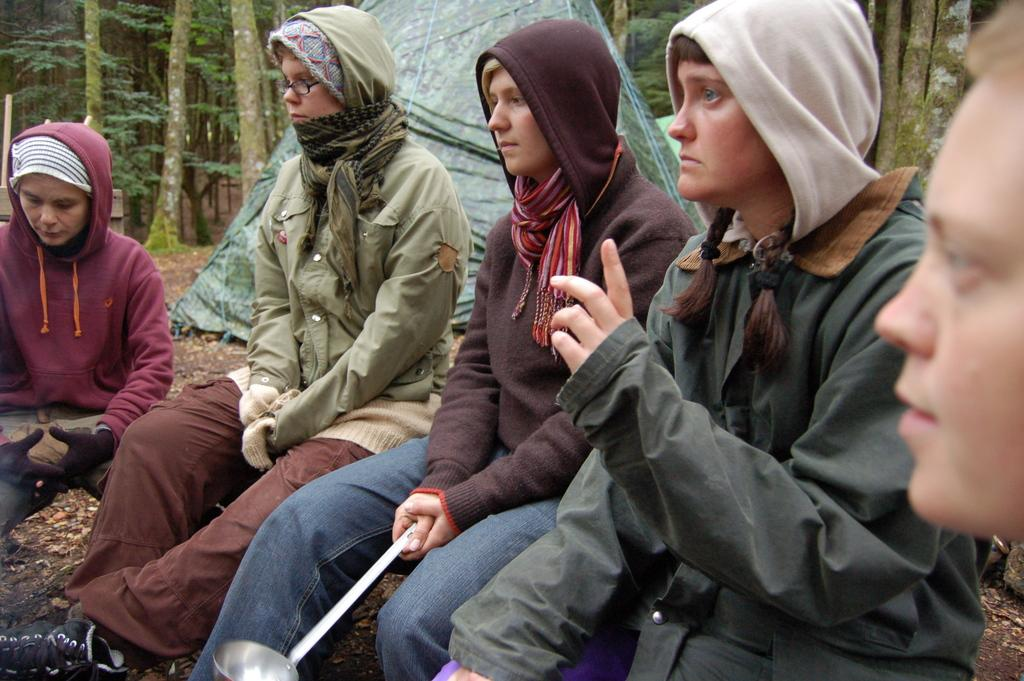What are the people in the foreground of the image doing? The people in the foreground of the image are sitting. What is the person in the center of the image holding? The person in the center of the image is holding a spatula. What can be seen in the background of the image? There are trees and a tent in the background of the image. What type of hen can be seen eating oatmeal in the image? There is no hen or oatmeal present in the image. Is the lettuce in the image being used as a tablecloth? There is no lettuce present in the image. 